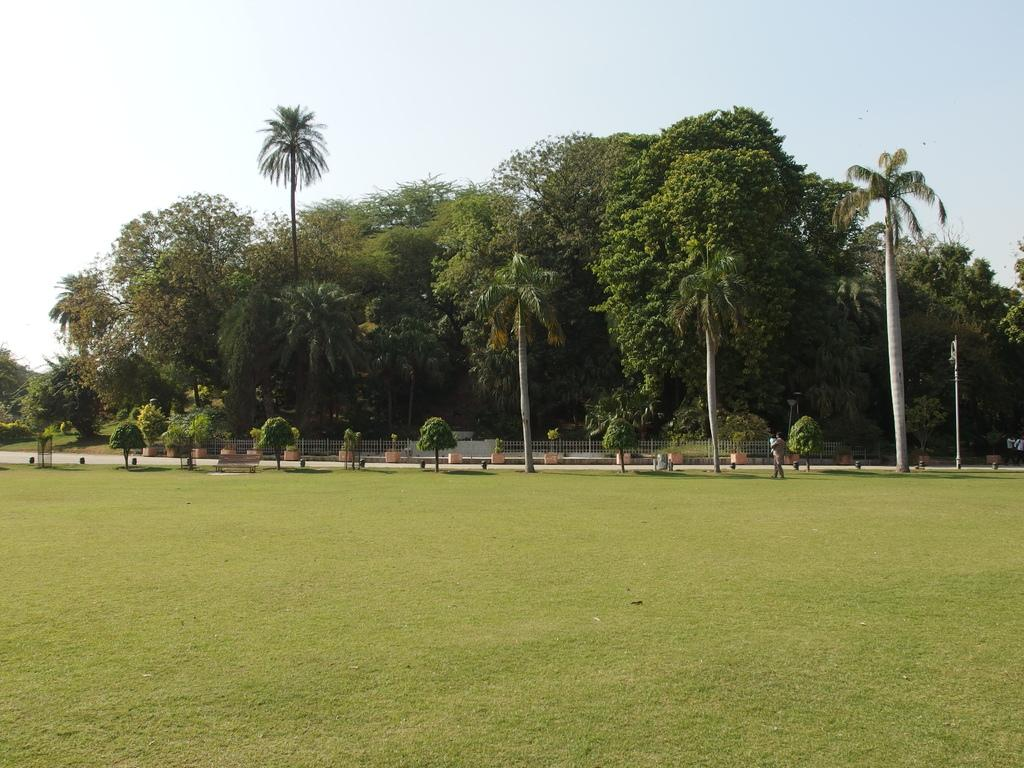What type of outdoor space is depicted in the image? There is a garden in the image. What can be seen behind the garden? There are trees behind the garden. Is there any activity taking place in the garden? Yes, there is a person walking in the garden. Can you describe the person's location in relation to the trees? The person is walking in front of one of the trees. What advice does the person's mom give them while walking in the garden? There is no mention of a mom or any advice in the image, so we cannot answer this question. 